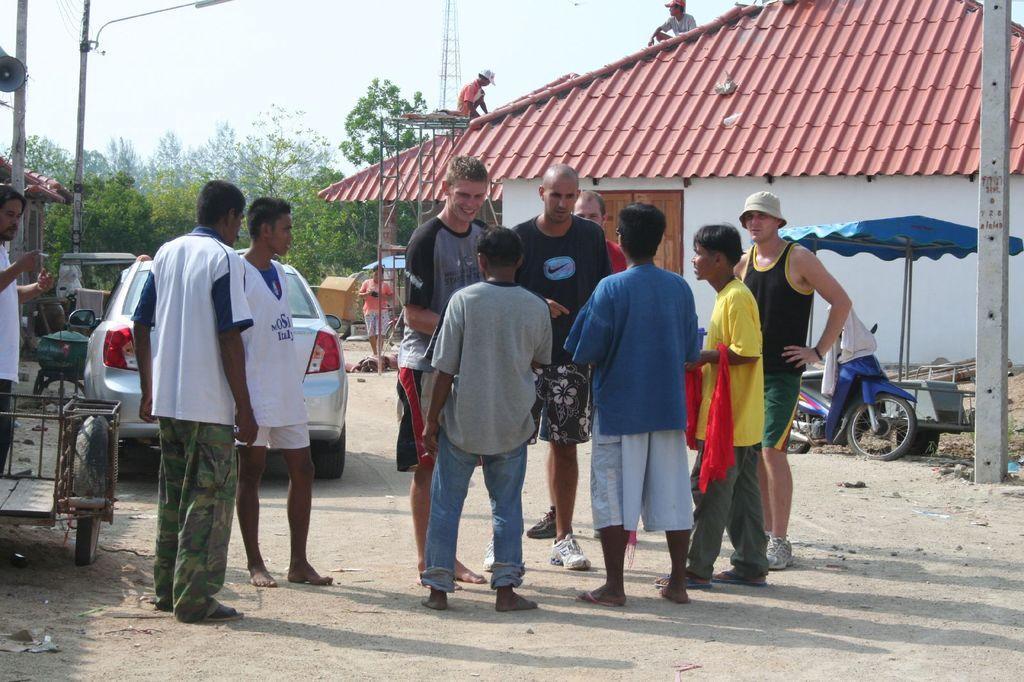In one or two sentences, can you explain what this image depicts? In this image in the center there are persons standing. In the background there are vehicles, trees, poles and there is a house and on the top of the house, there are persons. On the right side there is a tent which is blue in colour and there is a pole. 